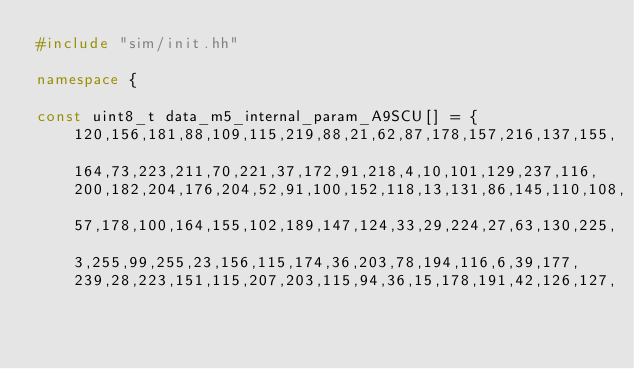Convert code to text. <code><loc_0><loc_0><loc_500><loc_500><_C++_>#include "sim/init.hh"

namespace {

const uint8_t data_m5_internal_param_A9SCU[] = {
    120,156,181,88,109,115,219,88,21,62,87,178,157,216,137,155,
    164,73,223,211,70,221,37,172,91,218,4,10,101,129,237,116,
    200,182,204,176,204,52,91,100,152,118,13,131,86,145,110,108,
    57,178,100,164,155,102,189,147,124,33,29,224,27,63,130,225,
    3,255,99,255,23,156,115,174,36,203,78,194,116,6,39,177,
    239,28,223,151,115,207,203,115,94,36,15,178,191,42,126,127,</code> 